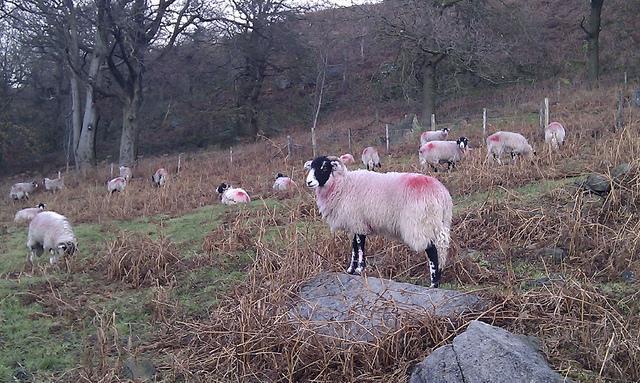How many types of livestock are shown?
Give a very brief answer. 1. How many people have dress ties on?
Give a very brief answer. 0. 